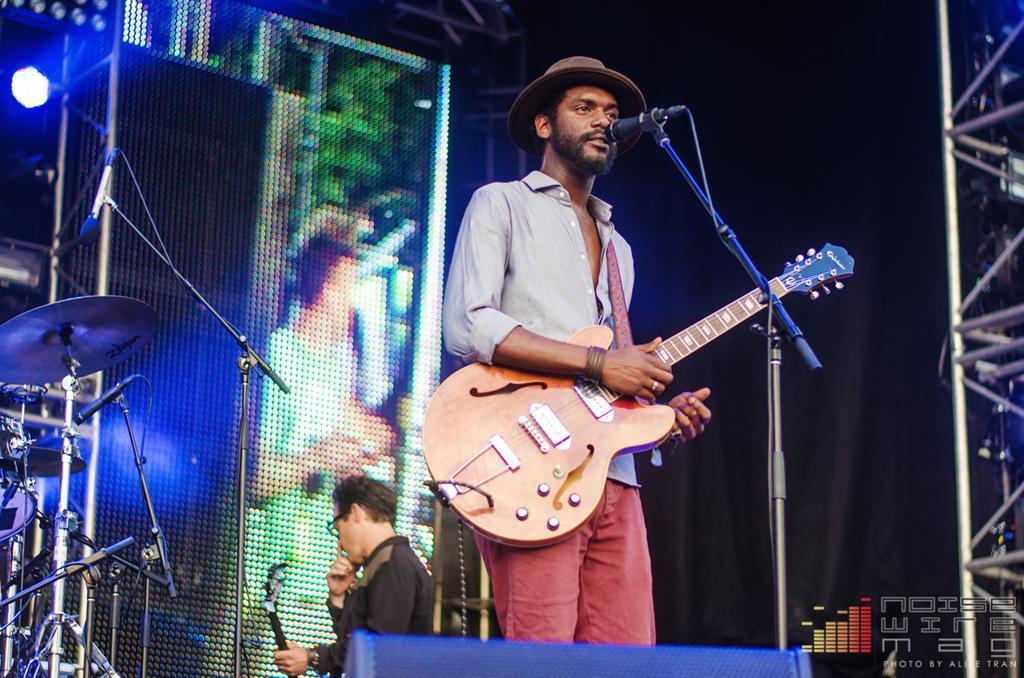Can you describe this image briefly? Two persons are there. This person standing and holding guitar. There is a microphone with stand. On the background we can see musical instrument and focusing lights. 